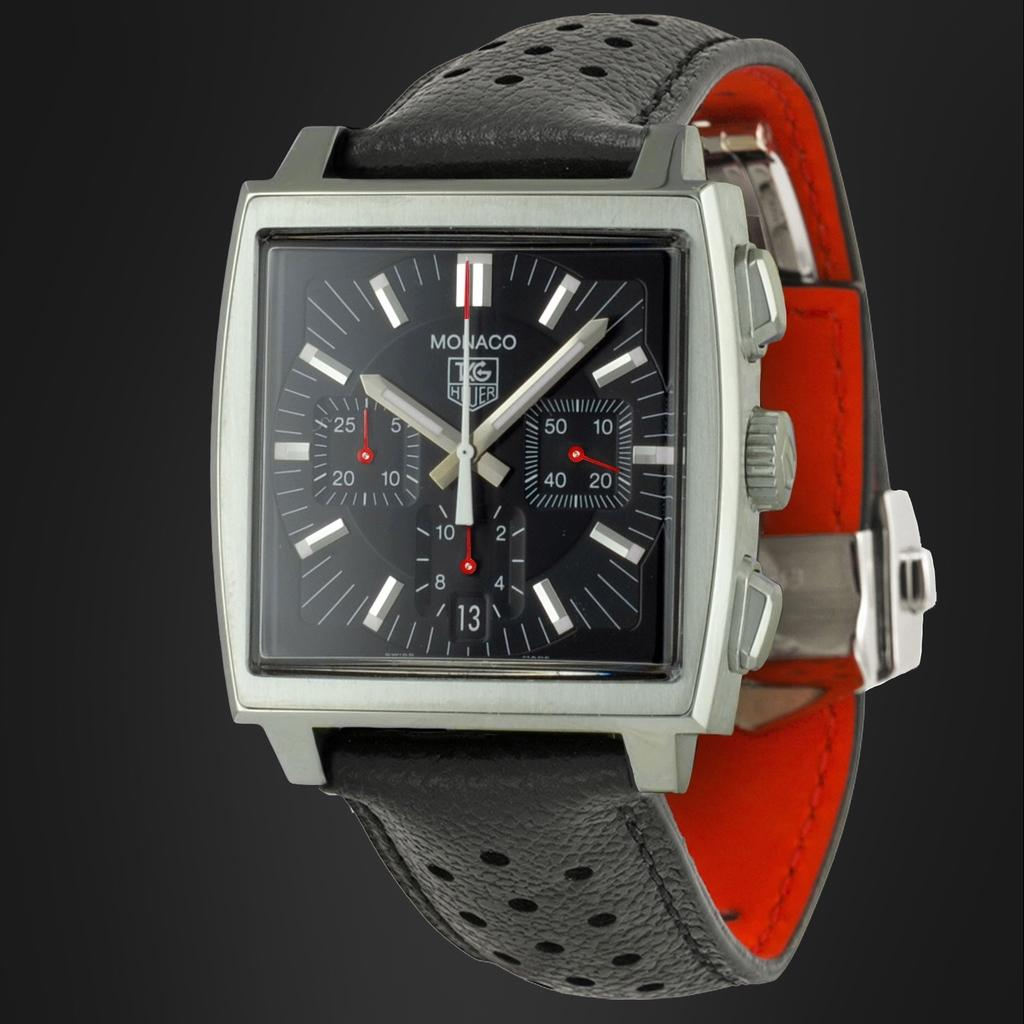<image>
Summarize the visual content of the image. Monaco TKG Hiuer watch that says it is 10:07, with minute hand pointing at 12. 